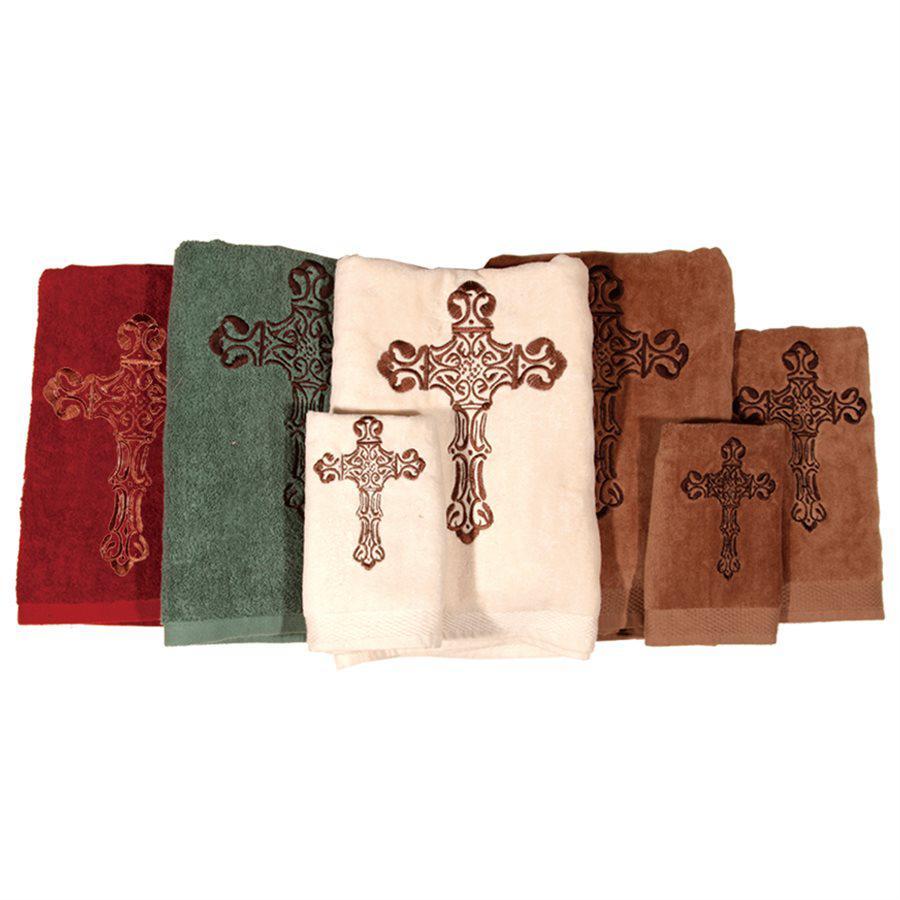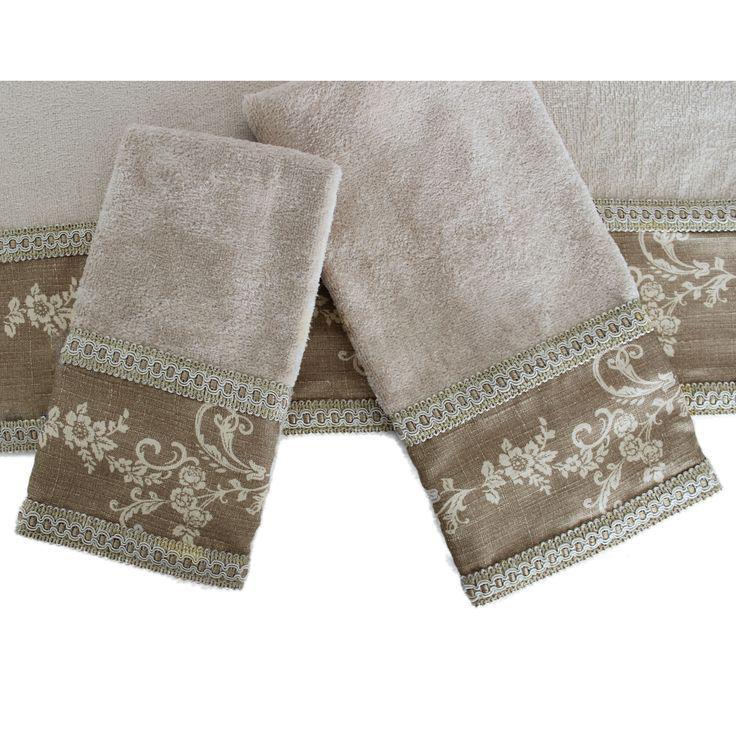The first image is the image on the left, the second image is the image on the right. Considering the images on both sides, is "The linens in the image on the right are red" valid? Answer yes or no. No. 